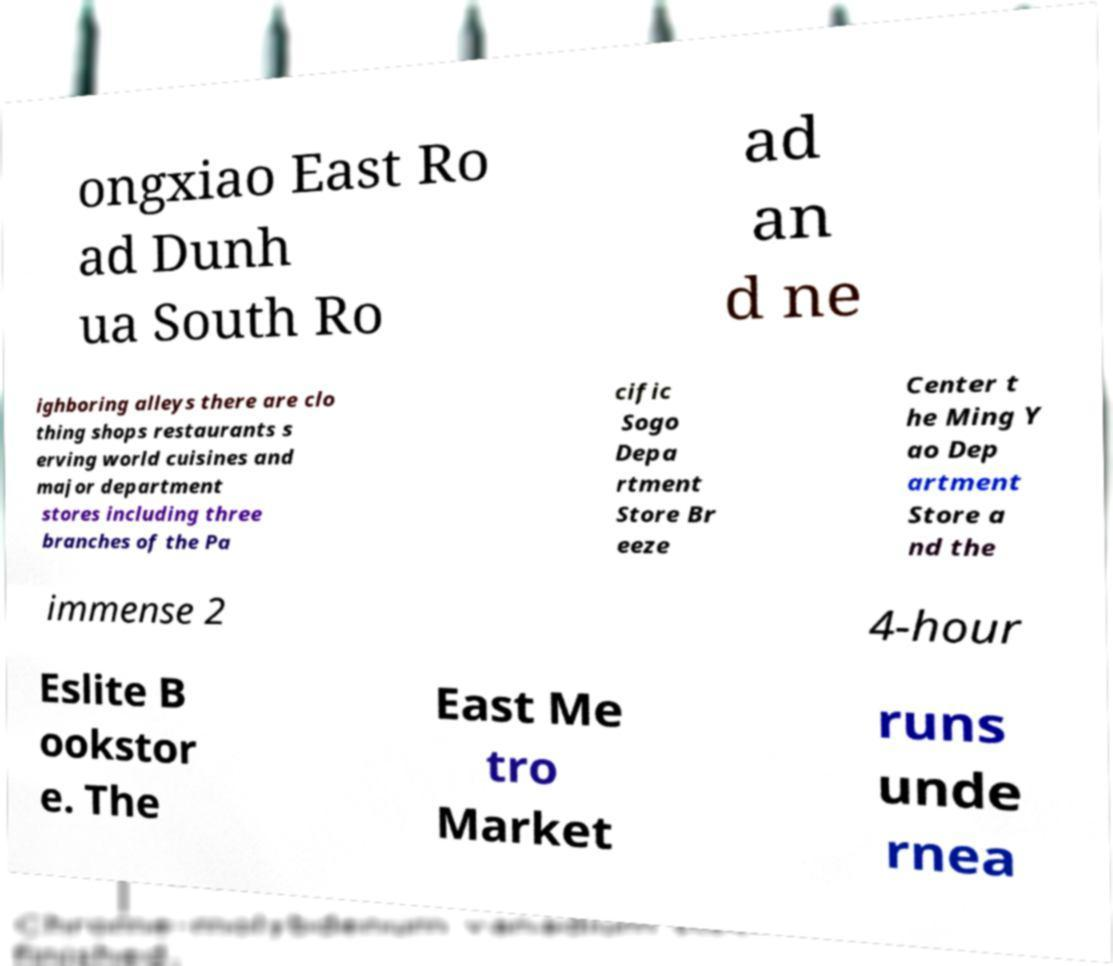There's text embedded in this image that I need extracted. Can you transcribe it verbatim? ongxiao East Ro ad Dunh ua South Ro ad an d ne ighboring alleys there are clo thing shops restaurants s erving world cuisines and major department stores including three branches of the Pa cific Sogo Depa rtment Store Br eeze Center t he Ming Y ao Dep artment Store a nd the immense 2 4-hour Eslite B ookstor e. The East Me tro Market runs unde rnea 